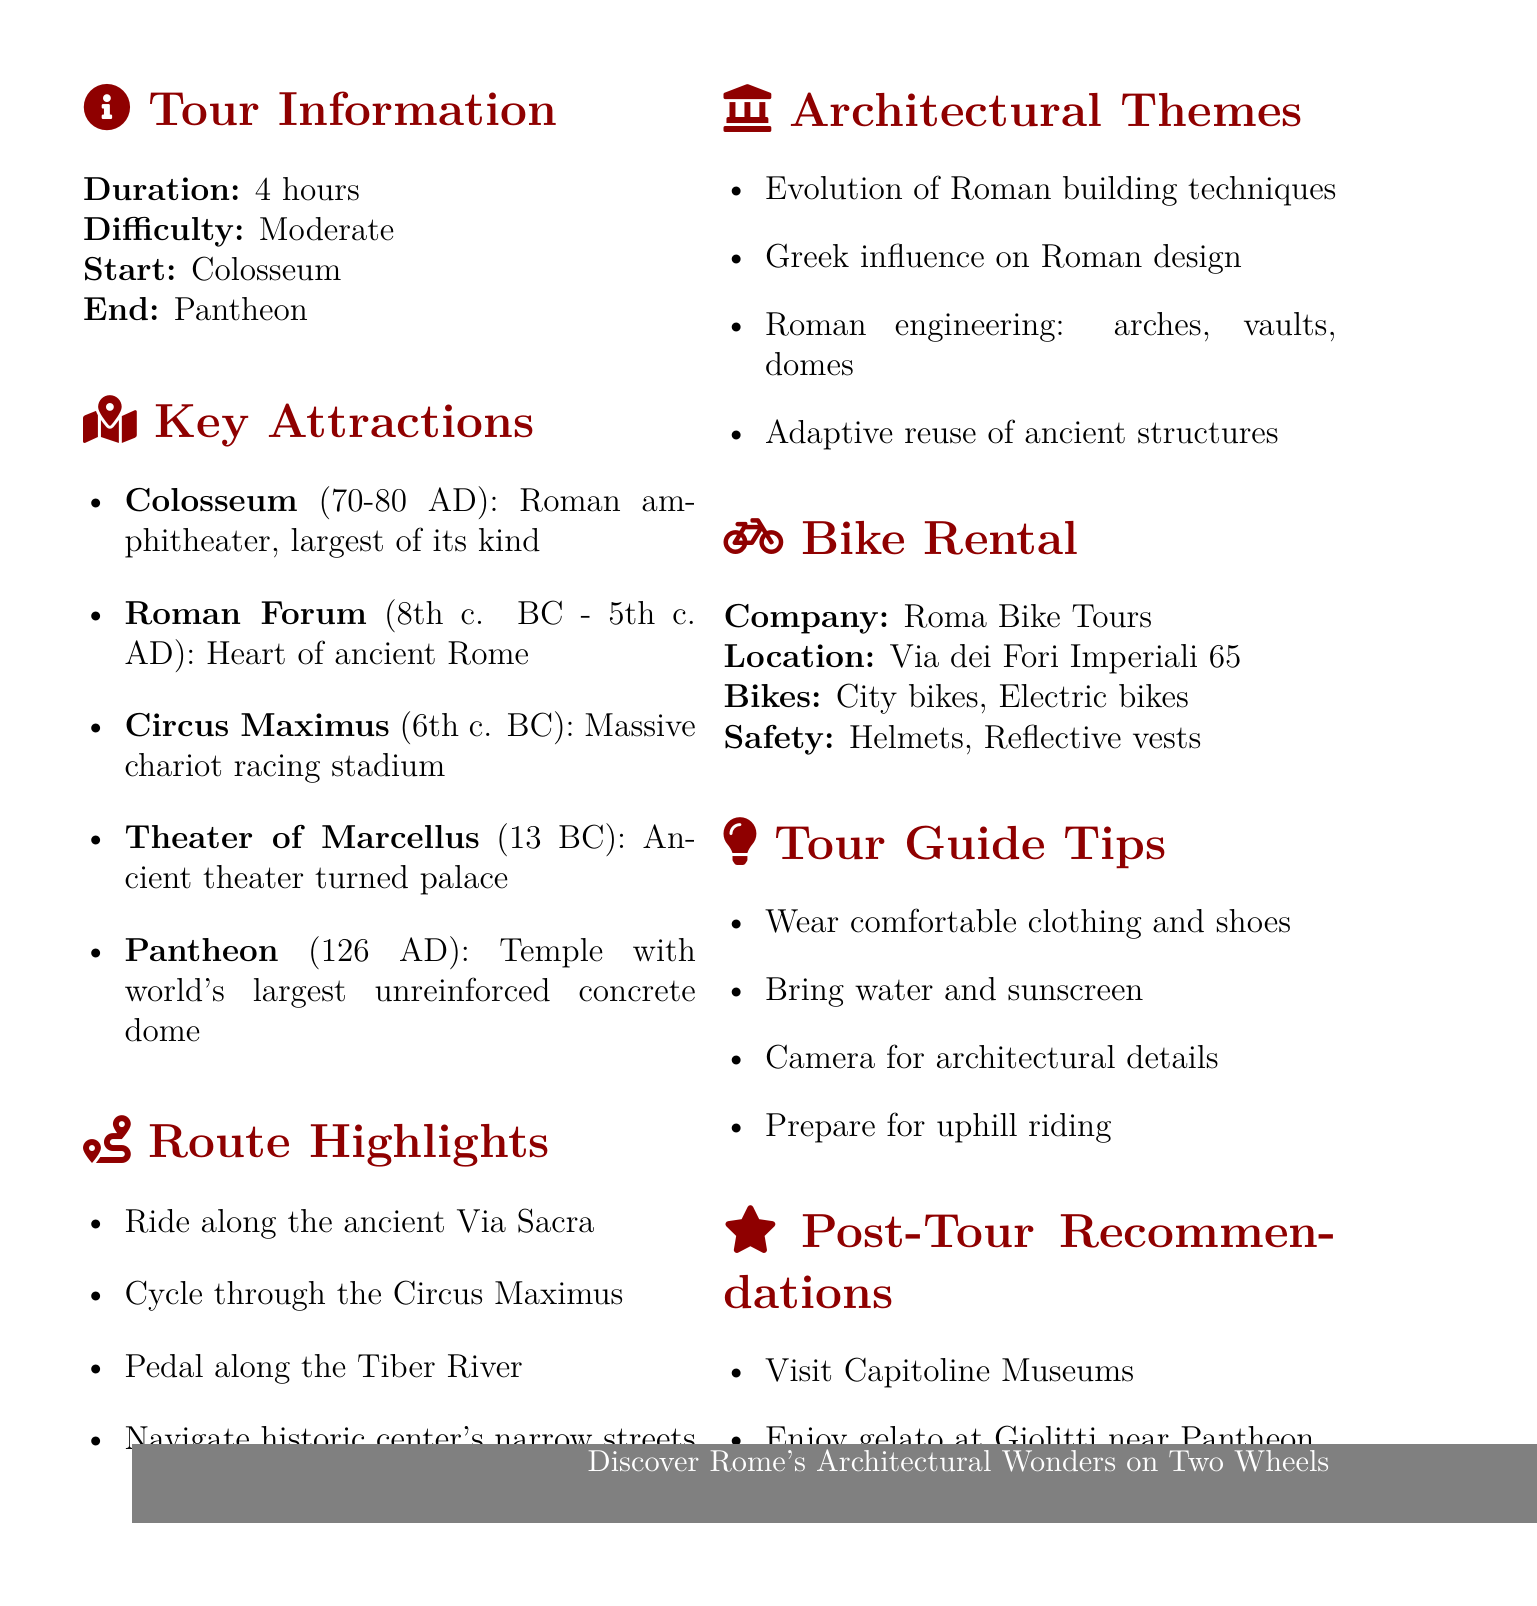What is the duration of the tour? The duration of the tour is stated explicitly in the document as "4 hours."
Answer: 4 hours What is the starting point of the bike tour? The document specifies the starting point of the bike tour as the "Colosseum."
Answer: Colosseum How many key attractions are listed in the document? The document lists five key attractions under the section "Key Attractions."
Answer: 5 What is the architectural style of the Pantheon? The architectural style of the Pantheon is mentioned in the document as "Roman temple."
Answer: Roman temple Which bike rental company is mentioned? The bike rental company mentioned in the document is "Roma Bike Tours."
Answer: Roma Bike Tours What type of safety equipment is provided? The document lists "Helmets" and "Reflective vests" as safety equipment provided.
Answer: Helmets, Reflective vests What is one architectural theme discussed on the tour? The document identifies multiple themes, one of which is the "Evolution of Roman building techniques."
Answer: Evolution of Roman building techniques What is the recommended post-tour activity? The document recommends visiting the "Capitoline Museums" as a post-tour activity.
Answer: Visit the Capitoline Museums 